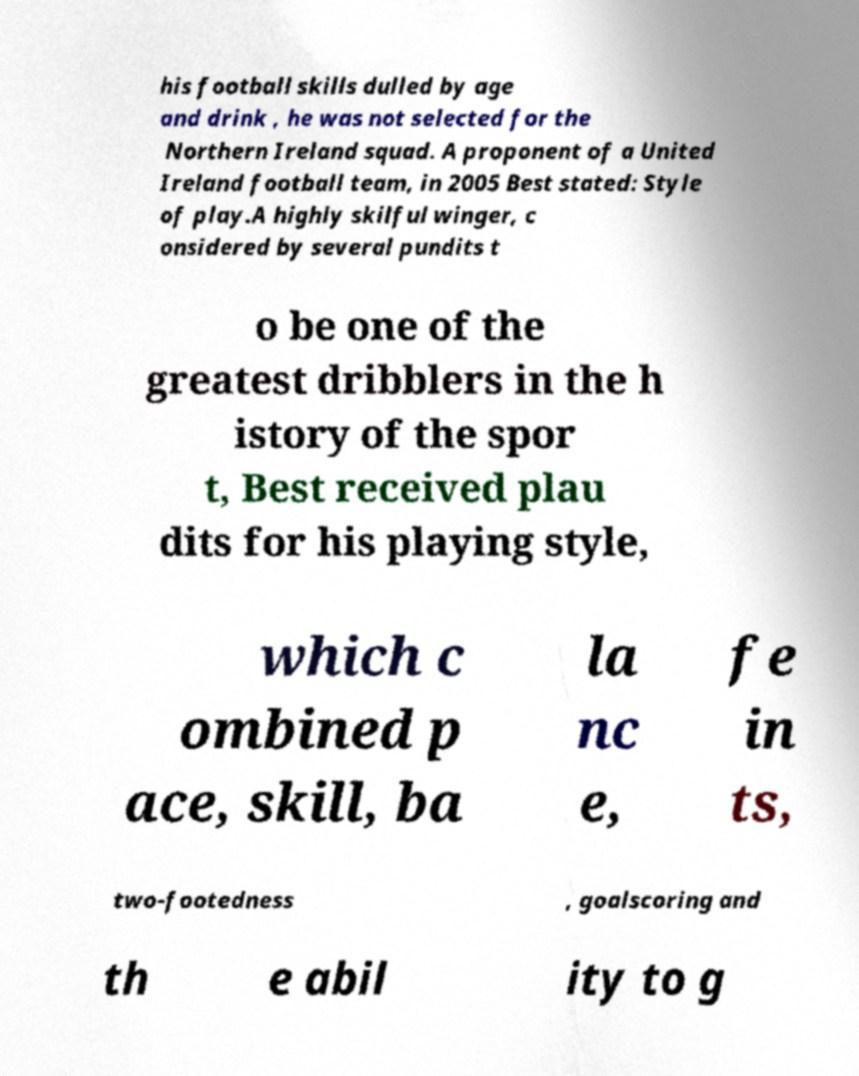For documentation purposes, I need the text within this image transcribed. Could you provide that? his football skills dulled by age and drink , he was not selected for the Northern Ireland squad. A proponent of a United Ireland football team, in 2005 Best stated: Style of play.A highly skilful winger, c onsidered by several pundits t o be one of the greatest dribblers in the h istory of the spor t, Best received plau dits for his playing style, which c ombined p ace, skill, ba la nc e, fe in ts, two-footedness , goalscoring and th e abil ity to g 